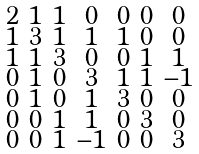Convert formula to latex. <formula><loc_0><loc_0><loc_500><loc_500>\begin{smallmatrix} 2 & 1 & 1 & 0 & 0 & 0 & 0 \\ 1 & 3 & 1 & 1 & 1 & 0 & 0 \\ 1 & 1 & 3 & 0 & 0 & 1 & 1 \\ 0 & 1 & 0 & 3 & 1 & 1 & - 1 \\ 0 & 1 & 0 & 1 & 3 & 0 & 0 \\ 0 & 0 & 1 & 1 & 0 & 3 & 0 \\ 0 & 0 & 1 & - 1 & 0 & 0 & 3 \end{smallmatrix}</formula> 